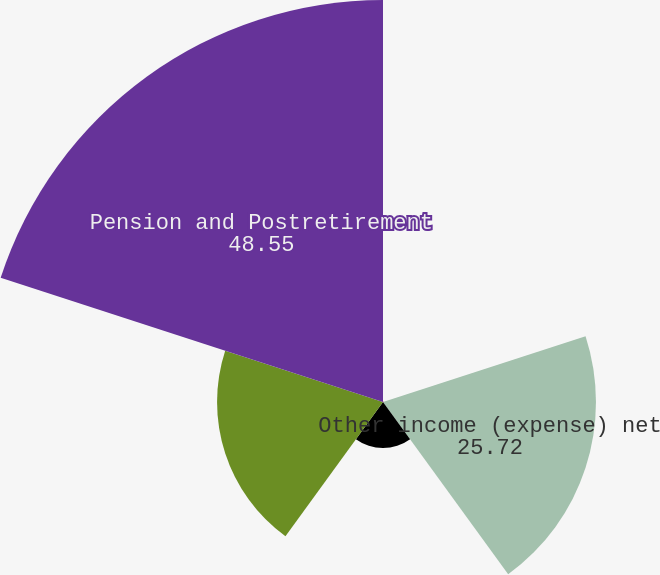<chart> <loc_0><loc_0><loc_500><loc_500><pie_chart><fcel>Sales/Cost of sales<fcel>Other income (expense) net<fcel>Interest expense<fcel>Total (Gain) Loss on Cash Flow<fcel>Pension and Postretirement<nl><fcel>0.11%<fcel>25.72%<fcel>5.57%<fcel>20.04%<fcel>48.55%<nl></chart> 